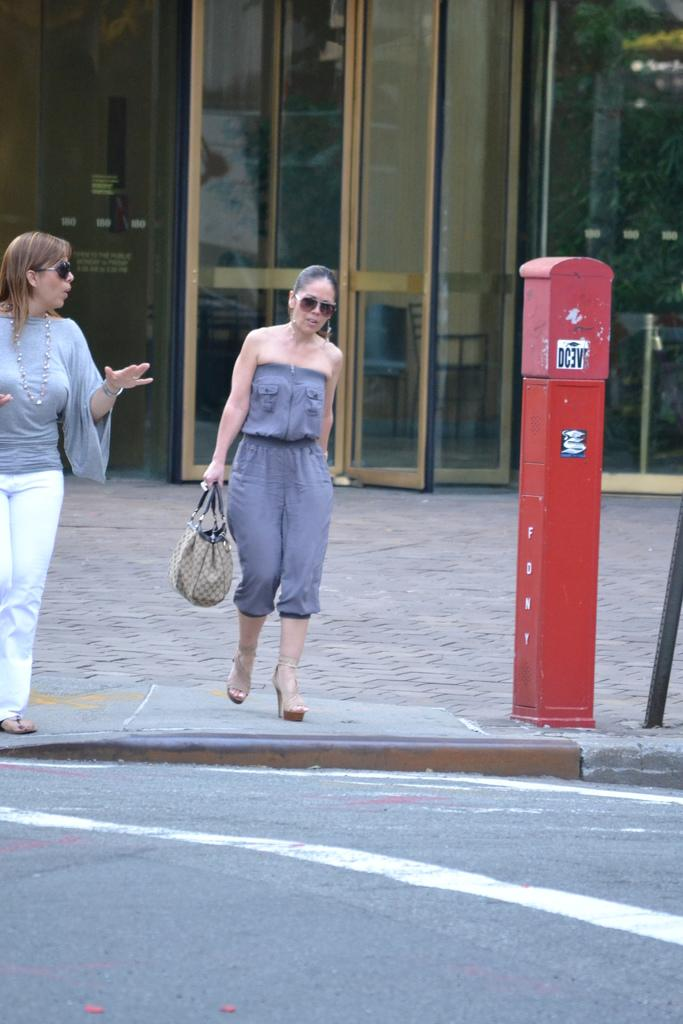How many women are present in the image? There are two women in the image. What are the women doing in the image? The women are crossing the road. Where is the market located in the image? There is no market present in the image. What type of spark can be seen coming from the women's shoes in the image? There is no spark visible in the image. What type of cracker is the woman on the left holding in the image? There is no cracker present in the image. 